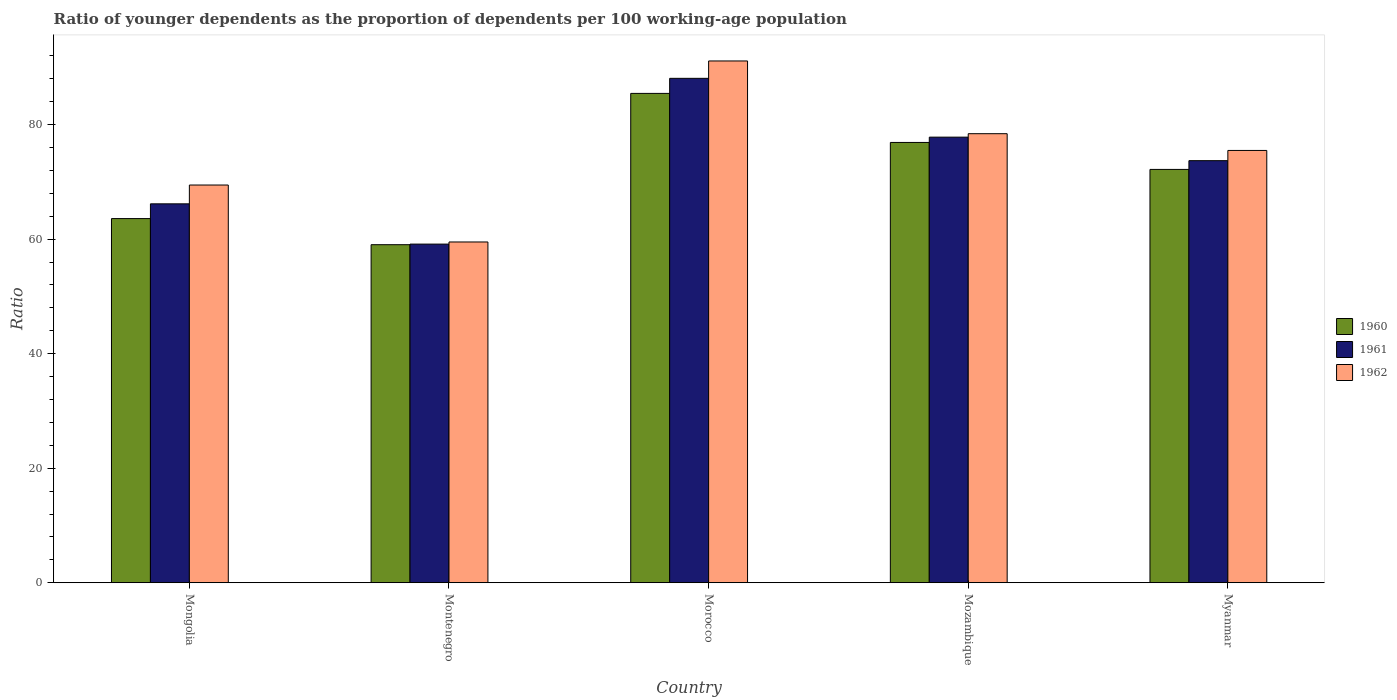How many different coloured bars are there?
Provide a succinct answer. 3. Are the number of bars on each tick of the X-axis equal?
Ensure brevity in your answer.  Yes. How many bars are there on the 3rd tick from the right?
Provide a succinct answer. 3. What is the label of the 4th group of bars from the left?
Keep it short and to the point. Mozambique. In how many cases, is the number of bars for a given country not equal to the number of legend labels?
Offer a terse response. 0. What is the age dependency ratio(young) in 1962 in Montenegro?
Provide a short and direct response. 59.51. Across all countries, what is the maximum age dependency ratio(young) in 1962?
Provide a short and direct response. 91.12. Across all countries, what is the minimum age dependency ratio(young) in 1961?
Provide a succinct answer. 59.14. In which country was the age dependency ratio(young) in 1960 maximum?
Give a very brief answer. Morocco. In which country was the age dependency ratio(young) in 1961 minimum?
Your response must be concise. Montenegro. What is the total age dependency ratio(young) in 1962 in the graph?
Make the answer very short. 374. What is the difference between the age dependency ratio(young) in 1961 in Montenegro and that in Mozambique?
Your answer should be compact. -18.68. What is the difference between the age dependency ratio(young) in 1962 in Morocco and the age dependency ratio(young) in 1961 in Mongolia?
Ensure brevity in your answer.  24.95. What is the average age dependency ratio(young) in 1961 per country?
Ensure brevity in your answer.  72.98. What is the difference between the age dependency ratio(young) of/in 1961 and age dependency ratio(young) of/in 1960 in Myanmar?
Make the answer very short. 1.53. What is the ratio of the age dependency ratio(young) in 1960 in Morocco to that in Myanmar?
Offer a very short reply. 1.18. Is the difference between the age dependency ratio(young) in 1961 in Montenegro and Myanmar greater than the difference between the age dependency ratio(young) in 1960 in Montenegro and Myanmar?
Provide a short and direct response. No. What is the difference between the highest and the second highest age dependency ratio(young) in 1961?
Give a very brief answer. 14.38. What is the difference between the highest and the lowest age dependency ratio(young) in 1960?
Give a very brief answer. 26.42. In how many countries, is the age dependency ratio(young) in 1961 greater than the average age dependency ratio(young) in 1961 taken over all countries?
Give a very brief answer. 3. What does the 3rd bar from the left in Mozambique represents?
Give a very brief answer. 1962. How many bars are there?
Provide a short and direct response. 15. Are the values on the major ticks of Y-axis written in scientific E-notation?
Offer a very short reply. No. Does the graph contain any zero values?
Your answer should be compact. No. Where does the legend appear in the graph?
Make the answer very short. Center right. What is the title of the graph?
Your response must be concise. Ratio of younger dependents as the proportion of dependents per 100 working-age population. Does "1988" appear as one of the legend labels in the graph?
Provide a short and direct response. No. What is the label or title of the Y-axis?
Make the answer very short. Ratio. What is the Ratio of 1960 in Mongolia?
Offer a very short reply. 63.59. What is the Ratio in 1961 in Mongolia?
Ensure brevity in your answer.  66.17. What is the Ratio of 1962 in Mongolia?
Offer a terse response. 69.46. What is the Ratio in 1960 in Montenegro?
Offer a terse response. 59.03. What is the Ratio in 1961 in Montenegro?
Ensure brevity in your answer.  59.14. What is the Ratio of 1962 in Montenegro?
Keep it short and to the point. 59.51. What is the Ratio in 1960 in Morocco?
Offer a terse response. 85.46. What is the Ratio in 1961 in Morocco?
Offer a terse response. 88.09. What is the Ratio in 1962 in Morocco?
Ensure brevity in your answer.  91.12. What is the Ratio in 1960 in Mozambique?
Offer a terse response. 76.89. What is the Ratio in 1961 in Mozambique?
Your response must be concise. 77.82. What is the Ratio in 1962 in Mozambique?
Your answer should be compact. 78.42. What is the Ratio of 1960 in Myanmar?
Offer a very short reply. 72.18. What is the Ratio of 1961 in Myanmar?
Your answer should be compact. 73.71. What is the Ratio of 1962 in Myanmar?
Ensure brevity in your answer.  75.49. Across all countries, what is the maximum Ratio of 1960?
Provide a short and direct response. 85.46. Across all countries, what is the maximum Ratio in 1961?
Your answer should be very brief. 88.09. Across all countries, what is the maximum Ratio in 1962?
Your answer should be very brief. 91.12. Across all countries, what is the minimum Ratio in 1960?
Your answer should be very brief. 59.03. Across all countries, what is the minimum Ratio in 1961?
Keep it short and to the point. 59.14. Across all countries, what is the minimum Ratio of 1962?
Ensure brevity in your answer.  59.51. What is the total Ratio of 1960 in the graph?
Keep it short and to the point. 357.16. What is the total Ratio in 1961 in the graph?
Your answer should be very brief. 364.92. What is the total Ratio of 1962 in the graph?
Offer a terse response. 374. What is the difference between the Ratio in 1960 in Mongolia and that in Montenegro?
Your response must be concise. 4.56. What is the difference between the Ratio in 1961 in Mongolia and that in Montenegro?
Make the answer very short. 7.03. What is the difference between the Ratio in 1962 in Mongolia and that in Montenegro?
Provide a short and direct response. 9.95. What is the difference between the Ratio of 1960 in Mongolia and that in Morocco?
Make the answer very short. -21.86. What is the difference between the Ratio in 1961 in Mongolia and that in Morocco?
Make the answer very short. -21.92. What is the difference between the Ratio of 1962 in Mongolia and that in Morocco?
Provide a short and direct response. -21.67. What is the difference between the Ratio in 1960 in Mongolia and that in Mozambique?
Offer a very short reply. -13.3. What is the difference between the Ratio in 1961 in Mongolia and that in Mozambique?
Provide a succinct answer. -11.65. What is the difference between the Ratio of 1962 in Mongolia and that in Mozambique?
Keep it short and to the point. -8.96. What is the difference between the Ratio in 1960 in Mongolia and that in Myanmar?
Provide a short and direct response. -8.59. What is the difference between the Ratio in 1961 in Mongolia and that in Myanmar?
Keep it short and to the point. -7.54. What is the difference between the Ratio in 1962 in Mongolia and that in Myanmar?
Keep it short and to the point. -6.04. What is the difference between the Ratio of 1960 in Montenegro and that in Morocco?
Offer a terse response. -26.42. What is the difference between the Ratio of 1961 in Montenegro and that in Morocco?
Give a very brief answer. -28.95. What is the difference between the Ratio of 1962 in Montenegro and that in Morocco?
Offer a terse response. -31.61. What is the difference between the Ratio of 1960 in Montenegro and that in Mozambique?
Make the answer very short. -17.86. What is the difference between the Ratio of 1961 in Montenegro and that in Mozambique?
Make the answer very short. -18.68. What is the difference between the Ratio of 1962 in Montenegro and that in Mozambique?
Give a very brief answer. -18.91. What is the difference between the Ratio of 1960 in Montenegro and that in Myanmar?
Offer a very short reply. -13.15. What is the difference between the Ratio in 1961 in Montenegro and that in Myanmar?
Your answer should be compact. -14.57. What is the difference between the Ratio of 1962 in Montenegro and that in Myanmar?
Offer a very short reply. -15.98. What is the difference between the Ratio in 1960 in Morocco and that in Mozambique?
Your answer should be compact. 8.57. What is the difference between the Ratio in 1961 in Morocco and that in Mozambique?
Your answer should be very brief. 10.27. What is the difference between the Ratio of 1962 in Morocco and that in Mozambique?
Provide a short and direct response. 12.7. What is the difference between the Ratio in 1960 in Morocco and that in Myanmar?
Provide a succinct answer. 13.28. What is the difference between the Ratio in 1961 in Morocco and that in Myanmar?
Give a very brief answer. 14.38. What is the difference between the Ratio of 1962 in Morocco and that in Myanmar?
Provide a succinct answer. 15.63. What is the difference between the Ratio of 1960 in Mozambique and that in Myanmar?
Make the answer very short. 4.71. What is the difference between the Ratio of 1961 in Mozambique and that in Myanmar?
Provide a succinct answer. 4.11. What is the difference between the Ratio of 1962 in Mozambique and that in Myanmar?
Provide a succinct answer. 2.92. What is the difference between the Ratio in 1960 in Mongolia and the Ratio in 1961 in Montenegro?
Make the answer very short. 4.46. What is the difference between the Ratio in 1960 in Mongolia and the Ratio in 1962 in Montenegro?
Ensure brevity in your answer.  4.08. What is the difference between the Ratio of 1961 in Mongolia and the Ratio of 1962 in Montenegro?
Provide a succinct answer. 6.66. What is the difference between the Ratio of 1960 in Mongolia and the Ratio of 1961 in Morocco?
Ensure brevity in your answer.  -24.49. What is the difference between the Ratio in 1960 in Mongolia and the Ratio in 1962 in Morocco?
Your answer should be compact. -27.53. What is the difference between the Ratio in 1961 in Mongolia and the Ratio in 1962 in Morocco?
Your answer should be compact. -24.95. What is the difference between the Ratio of 1960 in Mongolia and the Ratio of 1961 in Mozambique?
Offer a terse response. -14.22. What is the difference between the Ratio of 1960 in Mongolia and the Ratio of 1962 in Mozambique?
Your answer should be very brief. -14.82. What is the difference between the Ratio of 1961 in Mongolia and the Ratio of 1962 in Mozambique?
Provide a short and direct response. -12.25. What is the difference between the Ratio in 1960 in Mongolia and the Ratio in 1961 in Myanmar?
Offer a terse response. -10.12. What is the difference between the Ratio in 1960 in Mongolia and the Ratio in 1962 in Myanmar?
Keep it short and to the point. -11.9. What is the difference between the Ratio of 1961 in Mongolia and the Ratio of 1962 in Myanmar?
Ensure brevity in your answer.  -9.32. What is the difference between the Ratio of 1960 in Montenegro and the Ratio of 1961 in Morocco?
Make the answer very short. -29.05. What is the difference between the Ratio in 1960 in Montenegro and the Ratio in 1962 in Morocco?
Make the answer very short. -32.09. What is the difference between the Ratio of 1961 in Montenegro and the Ratio of 1962 in Morocco?
Offer a terse response. -31.98. What is the difference between the Ratio of 1960 in Montenegro and the Ratio of 1961 in Mozambique?
Make the answer very short. -18.78. What is the difference between the Ratio in 1960 in Montenegro and the Ratio in 1962 in Mozambique?
Offer a terse response. -19.39. What is the difference between the Ratio of 1961 in Montenegro and the Ratio of 1962 in Mozambique?
Keep it short and to the point. -19.28. What is the difference between the Ratio of 1960 in Montenegro and the Ratio of 1961 in Myanmar?
Keep it short and to the point. -14.68. What is the difference between the Ratio of 1960 in Montenegro and the Ratio of 1962 in Myanmar?
Give a very brief answer. -16.46. What is the difference between the Ratio of 1961 in Montenegro and the Ratio of 1962 in Myanmar?
Offer a terse response. -16.36. What is the difference between the Ratio of 1960 in Morocco and the Ratio of 1961 in Mozambique?
Give a very brief answer. 7.64. What is the difference between the Ratio in 1960 in Morocco and the Ratio in 1962 in Mozambique?
Offer a terse response. 7.04. What is the difference between the Ratio of 1961 in Morocco and the Ratio of 1962 in Mozambique?
Your response must be concise. 9.67. What is the difference between the Ratio in 1960 in Morocco and the Ratio in 1961 in Myanmar?
Make the answer very short. 11.75. What is the difference between the Ratio in 1960 in Morocco and the Ratio in 1962 in Myanmar?
Your answer should be very brief. 9.96. What is the difference between the Ratio of 1961 in Morocco and the Ratio of 1962 in Myanmar?
Offer a terse response. 12.59. What is the difference between the Ratio in 1960 in Mozambique and the Ratio in 1961 in Myanmar?
Your response must be concise. 3.18. What is the difference between the Ratio of 1960 in Mozambique and the Ratio of 1962 in Myanmar?
Provide a short and direct response. 1.4. What is the difference between the Ratio of 1961 in Mozambique and the Ratio of 1962 in Myanmar?
Offer a very short reply. 2.32. What is the average Ratio in 1960 per country?
Your response must be concise. 71.43. What is the average Ratio of 1961 per country?
Ensure brevity in your answer.  72.98. What is the average Ratio in 1962 per country?
Your response must be concise. 74.8. What is the difference between the Ratio of 1960 and Ratio of 1961 in Mongolia?
Offer a terse response. -2.58. What is the difference between the Ratio in 1960 and Ratio in 1962 in Mongolia?
Offer a terse response. -5.86. What is the difference between the Ratio of 1961 and Ratio of 1962 in Mongolia?
Make the answer very short. -3.28. What is the difference between the Ratio in 1960 and Ratio in 1961 in Montenegro?
Offer a terse response. -0.1. What is the difference between the Ratio in 1960 and Ratio in 1962 in Montenegro?
Keep it short and to the point. -0.48. What is the difference between the Ratio in 1961 and Ratio in 1962 in Montenegro?
Offer a very short reply. -0.37. What is the difference between the Ratio of 1960 and Ratio of 1961 in Morocco?
Offer a very short reply. -2.63. What is the difference between the Ratio in 1960 and Ratio in 1962 in Morocco?
Make the answer very short. -5.66. What is the difference between the Ratio of 1961 and Ratio of 1962 in Morocco?
Keep it short and to the point. -3.04. What is the difference between the Ratio of 1960 and Ratio of 1961 in Mozambique?
Offer a terse response. -0.93. What is the difference between the Ratio of 1960 and Ratio of 1962 in Mozambique?
Offer a terse response. -1.53. What is the difference between the Ratio in 1961 and Ratio in 1962 in Mozambique?
Your response must be concise. -0.6. What is the difference between the Ratio of 1960 and Ratio of 1961 in Myanmar?
Keep it short and to the point. -1.53. What is the difference between the Ratio in 1960 and Ratio in 1962 in Myanmar?
Offer a very short reply. -3.31. What is the difference between the Ratio in 1961 and Ratio in 1962 in Myanmar?
Your response must be concise. -1.78. What is the ratio of the Ratio in 1960 in Mongolia to that in Montenegro?
Offer a very short reply. 1.08. What is the ratio of the Ratio in 1961 in Mongolia to that in Montenegro?
Keep it short and to the point. 1.12. What is the ratio of the Ratio in 1962 in Mongolia to that in Montenegro?
Provide a short and direct response. 1.17. What is the ratio of the Ratio in 1960 in Mongolia to that in Morocco?
Provide a succinct answer. 0.74. What is the ratio of the Ratio of 1961 in Mongolia to that in Morocco?
Ensure brevity in your answer.  0.75. What is the ratio of the Ratio of 1962 in Mongolia to that in Morocco?
Give a very brief answer. 0.76. What is the ratio of the Ratio of 1960 in Mongolia to that in Mozambique?
Your answer should be compact. 0.83. What is the ratio of the Ratio of 1961 in Mongolia to that in Mozambique?
Offer a terse response. 0.85. What is the ratio of the Ratio in 1962 in Mongolia to that in Mozambique?
Offer a terse response. 0.89. What is the ratio of the Ratio in 1960 in Mongolia to that in Myanmar?
Provide a short and direct response. 0.88. What is the ratio of the Ratio of 1961 in Mongolia to that in Myanmar?
Ensure brevity in your answer.  0.9. What is the ratio of the Ratio of 1960 in Montenegro to that in Morocco?
Your answer should be compact. 0.69. What is the ratio of the Ratio in 1961 in Montenegro to that in Morocco?
Your response must be concise. 0.67. What is the ratio of the Ratio of 1962 in Montenegro to that in Morocco?
Keep it short and to the point. 0.65. What is the ratio of the Ratio of 1960 in Montenegro to that in Mozambique?
Your response must be concise. 0.77. What is the ratio of the Ratio in 1961 in Montenegro to that in Mozambique?
Offer a terse response. 0.76. What is the ratio of the Ratio of 1962 in Montenegro to that in Mozambique?
Your answer should be compact. 0.76. What is the ratio of the Ratio in 1960 in Montenegro to that in Myanmar?
Your response must be concise. 0.82. What is the ratio of the Ratio in 1961 in Montenegro to that in Myanmar?
Your answer should be very brief. 0.8. What is the ratio of the Ratio of 1962 in Montenegro to that in Myanmar?
Ensure brevity in your answer.  0.79. What is the ratio of the Ratio in 1960 in Morocco to that in Mozambique?
Make the answer very short. 1.11. What is the ratio of the Ratio in 1961 in Morocco to that in Mozambique?
Your response must be concise. 1.13. What is the ratio of the Ratio in 1962 in Morocco to that in Mozambique?
Make the answer very short. 1.16. What is the ratio of the Ratio in 1960 in Morocco to that in Myanmar?
Ensure brevity in your answer.  1.18. What is the ratio of the Ratio in 1961 in Morocco to that in Myanmar?
Make the answer very short. 1.2. What is the ratio of the Ratio of 1962 in Morocco to that in Myanmar?
Make the answer very short. 1.21. What is the ratio of the Ratio of 1960 in Mozambique to that in Myanmar?
Your response must be concise. 1.07. What is the ratio of the Ratio in 1961 in Mozambique to that in Myanmar?
Your response must be concise. 1.06. What is the ratio of the Ratio of 1962 in Mozambique to that in Myanmar?
Give a very brief answer. 1.04. What is the difference between the highest and the second highest Ratio of 1960?
Keep it short and to the point. 8.57. What is the difference between the highest and the second highest Ratio of 1961?
Make the answer very short. 10.27. What is the difference between the highest and the second highest Ratio in 1962?
Keep it short and to the point. 12.7. What is the difference between the highest and the lowest Ratio in 1960?
Ensure brevity in your answer.  26.42. What is the difference between the highest and the lowest Ratio of 1961?
Give a very brief answer. 28.95. What is the difference between the highest and the lowest Ratio of 1962?
Make the answer very short. 31.61. 